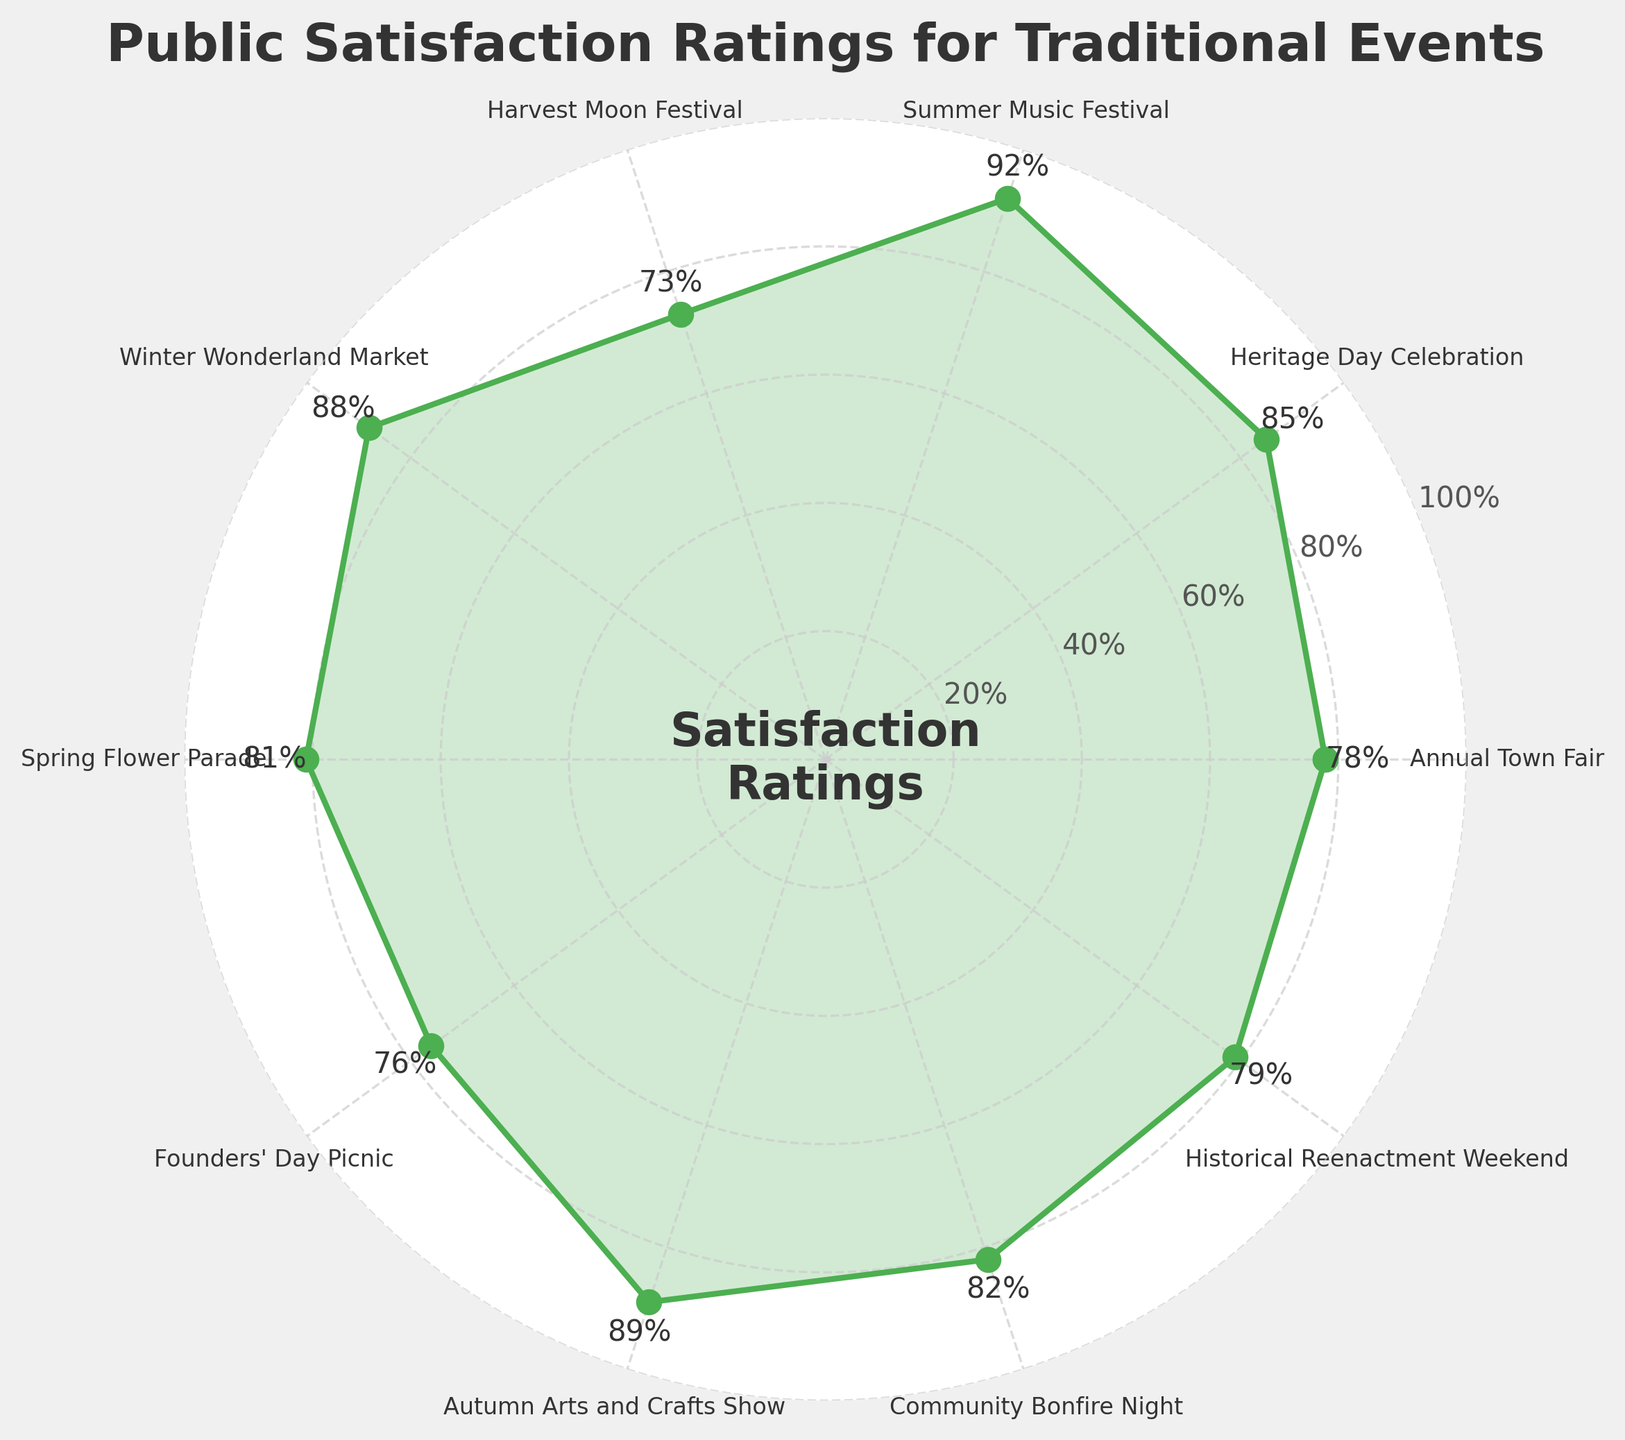What is the satisfaction rating of the Winter Wonderland Market? The satisfaction rating can be directly seen in the figure labels near the points. Look for the label corresponding to "Winter Wonderland Market".
Answer: 88% Which event has the highest satisfaction rating? Compare the values on the radial plot; the highest value will indicate the event with the highest satisfaction rating.
Answer: Summer Music Festival What is the average satisfaction rating of all the events? Sum all the satisfaction ratings and divide by the number of events. (78 + 85 + 92 + 73 + 88 + 81 + 76 + 89 + 82 + 79) / 10 = 80.3
Answer: 80.3% What is the difference between the highest and the lowest satisfaction rating? Identify the highest satisfaction rating (92) and the lowest (73), then subtract the lowest from the highest. 92 - 73 = 19
Answer: 19 How does the satisfaction rating of the Annual Town Fair compare to the Founders' Day Picnic? Find the ratings for "Annual Town Fair" (78) and "Founders' Day Picnic" (76) and determine if one is greater than or less than the other. 78 > 76
Answer: The Annual Town Fair has a higher rating Which event has a rating closest to 80%? Look at the ratings and find the one closest to 80. The events with ratings are: Annual Town Fair (78), Spring Flower Parade (81), and Historical Reenactment Weekend (79). Historical Reenactment Weekend (79) is closest.
Answer: Historical Reenactment Weekend Are there more events with a satisfaction rating above 80% or below 80%? Count the events above 80% and events below 80%. Above 80%: Heritage Day Celebration, Summer Music Festival, Winter Wonderland Market, Spring Flower Parade, Autumn Arts and Crafts Show, Community Bonfire Night (6). Below 80%: Annual Town Fair, Harvest Moon Festival, Founders' Day Picnic, Historical Reenactment Weekend (4).
Answer: More events above 80% What is the range of satisfaction ratings? The range is the difference between the highest and lowest data points. Highest: 92 (Summer Music Festival). Lowest: 73 (Harvest Moon Festival). Range: 92 - 73 = 19
Answer: 19 Is the satisfaction rating for the Autumn Arts and Crafts Show greater or less than the Community Bonfire Night? Compare the ratings for Autumn Arts and Crafts Show (89) and Community Bonfire Night (82). 89 > 82
Answer: Greater 